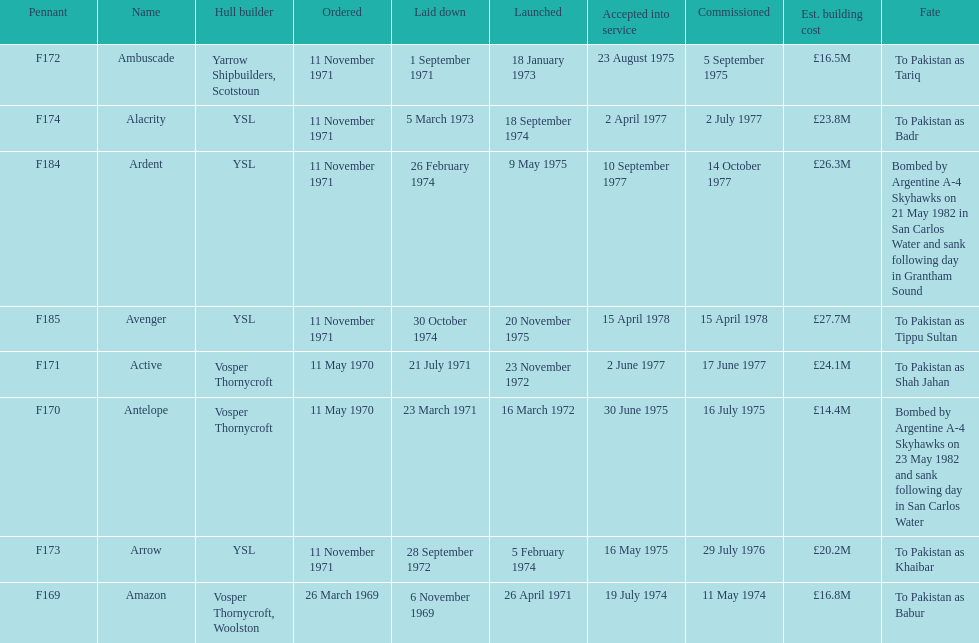How many ships were constructed in september? 2. 